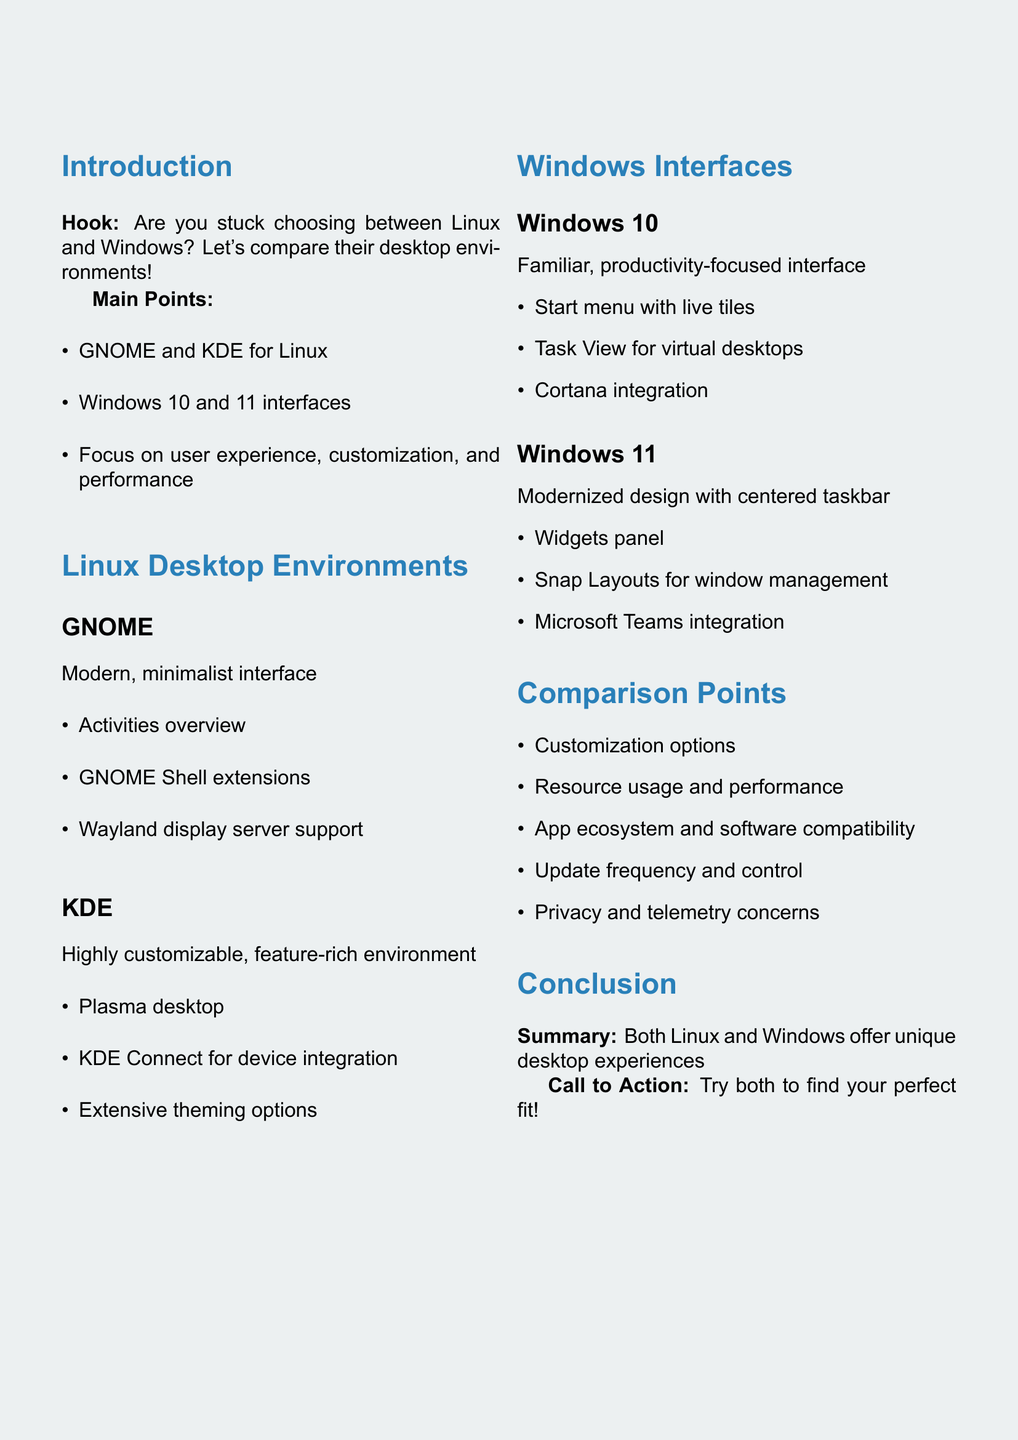What are the two Linux desktop environments mentioned? The document lists GNOME and KDE as the two Linux desktop environments.
Answer: GNOME and KDE What type of interface does GNOME offer? The document describes GNOME as having a modern, minimalist interface.
Answer: Modern, minimalist interface What feature is unique to Windows 11? The document notes that Windows 11 includes a widgets panel.
Answer: Widgets panel Which Linux desktop environment is known for extensive theming options? The document states that KDE is known for its extensive theming options.
Answer: KDE What is a common comparison point between Linux and Windows? The document lists multiple comparison points, including customization options.
Answer: Customization options Which version of Windows has Cortana integration? The document associates Cortana integration specifically with Windows 10.
Answer: Windows 10 What does the document suggest as a call to action? The conclusion section encourages users to try both operating systems to find their perfect fit.
Answer: Try both to find your perfect fit! What is the focus of the video according to the introduction? The introduction indicates that the focus is on user experience, customization, and performance.
Answer: User experience, customization, and performance How does KDE describe its environment? The document describes KDE as a highly customizable and feature-rich environment.
Answer: Highly customizable, feature-rich environment 